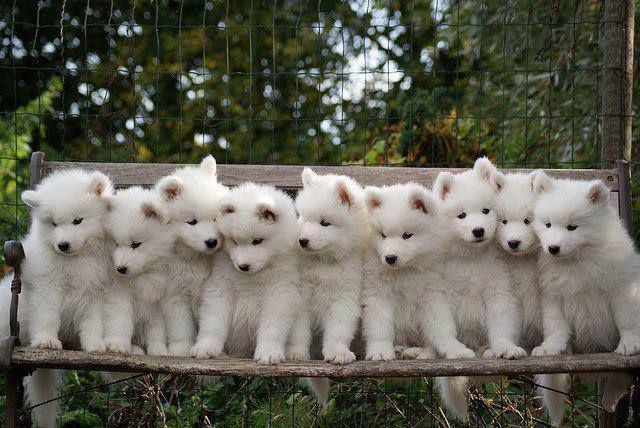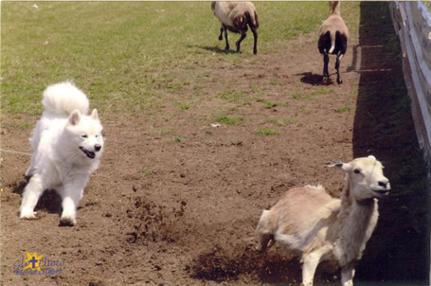The first image is the image on the left, the second image is the image on the right. For the images displayed, is the sentence "An image shows a white dog with a flock of ducks." factually correct? Answer yes or no. No. The first image is the image on the left, the second image is the image on the right. For the images displayed, is the sentence "there are exactly three sheep in one of the images" factually correct? Answer yes or no. No. 